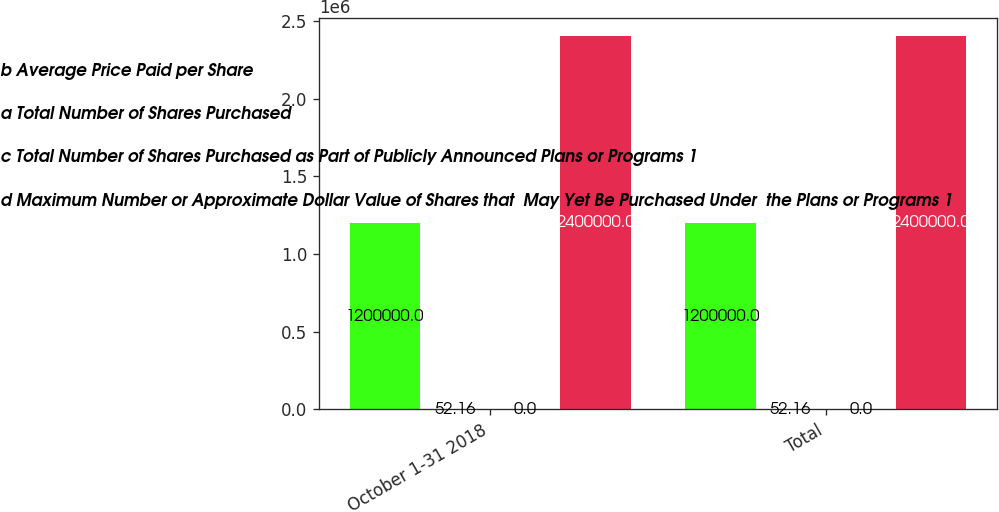Convert chart. <chart><loc_0><loc_0><loc_500><loc_500><stacked_bar_chart><ecel><fcel>October 1-31 2018<fcel>Total<nl><fcel>b Average Price Paid per Share<fcel>1.2e+06<fcel>1.2e+06<nl><fcel>a Total Number of Shares Purchased<fcel>52.16<fcel>52.16<nl><fcel>c Total Number of Shares Purchased as Part of Publicly Announced Plans or Programs 1<fcel>0<fcel>0<nl><fcel>d Maximum Number or Approximate Dollar Value of Shares that  May Yet Be Purchased Under  the Plans or Programs 1<fcel>2.4e+06<fcel>2.4e+06<nl></chart> 